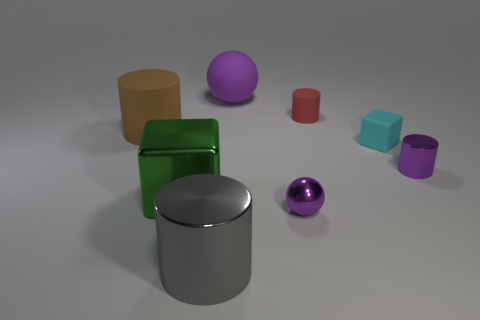The brown rubber thing that is the same shape as the red object is what size?
Offer a very short reply. Large. Are there more big cylinders behind the big green metallic block than large rubber things right of the purple metallic cylinder?
Make the answer very short. Yes. What number of spheres are either brown shiny objects or tiny purple metallic things?
Offer a very short reply. 1. There is a cube that is to the right of the large cylinder in front of the large cube; how many tiny blocks are in front of it?
Make the answer very short. 0. There is a large sphere that is the same color as the small shiny cylinder; what is its material?
Offer a very short reply. Rubber. Are there more small purple metallic cylinders than small cyan spheres?
Provide a succinct answer. Yes. Is the size of the red matte cylinder the same as the metallic block?
Provide a short and direct response. No. How many things are either large green metallic objects or metallic cylinders?
Your answer should be compact. 3. There is a purple metallic thing to the right of the ball in front of the matte cylinder left of the gray cylinder; what is its shape?
Offer a terse response. Cylinder. Is the cube right of the purple rubber ball made of the same material as the big object that is right of the large gray thing?
Offer a terse response. Yes. 